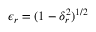Convert formula to latex. <formula><loc_0><loc_0><loc_500><loc_500>\epsilon _ { r } = ( 1 - \delta _ { r } ^ { 2 } ) ^ { 1 / 2 }</formula> 